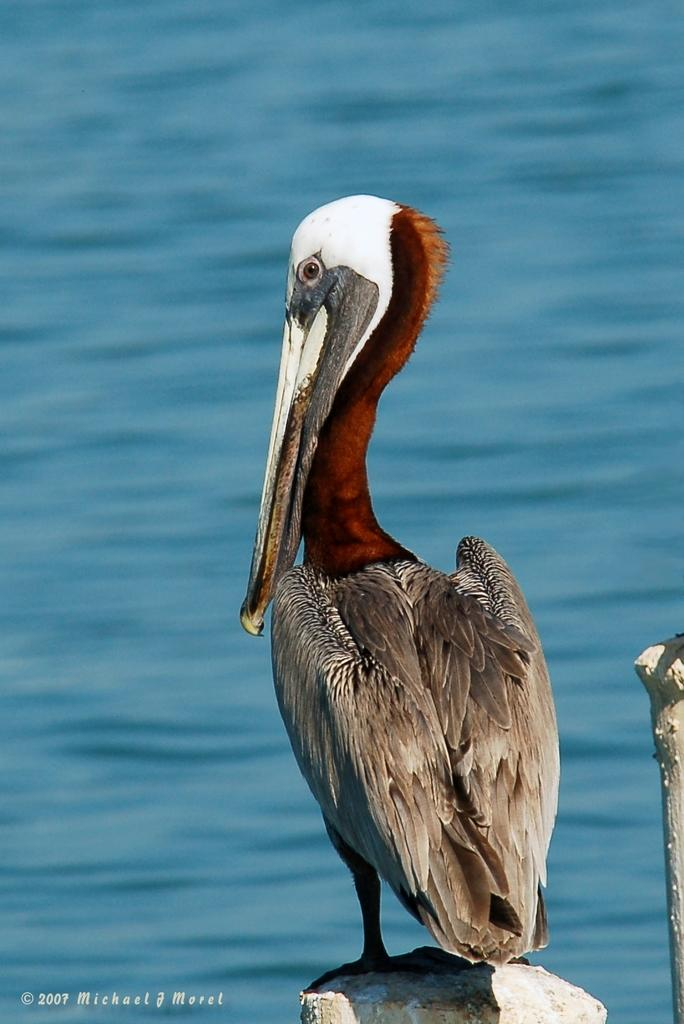What type of animal can be seen in the image? There is a bird in the image. What is visible in the background of the image? There is water visible behind the image. What type of pain is the bird experiencing in the image? There is no indication in the image that the bird is experiencing any pain. Where is the faucet located in the image? There is no faucet present in the image. What type of musical instrument is the bird playing in the image? There is no musical instrument, such as a guitar, present in the image. 